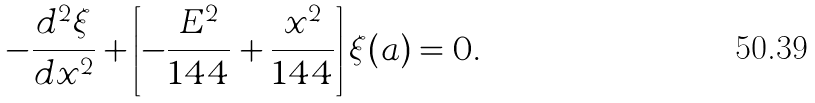<formula> <loc_0><loc_0><loc_500><loc_500>- \frac { d ^ { 2 } \xi } { d x ^ { 2 } } + \left [ - \frac { E ^ { 2 } } { 1 4 4 } + \frac { x ^ { 2 } } { 1 4 4 } \right ] \xi ( a ) = 0 .</formula> 